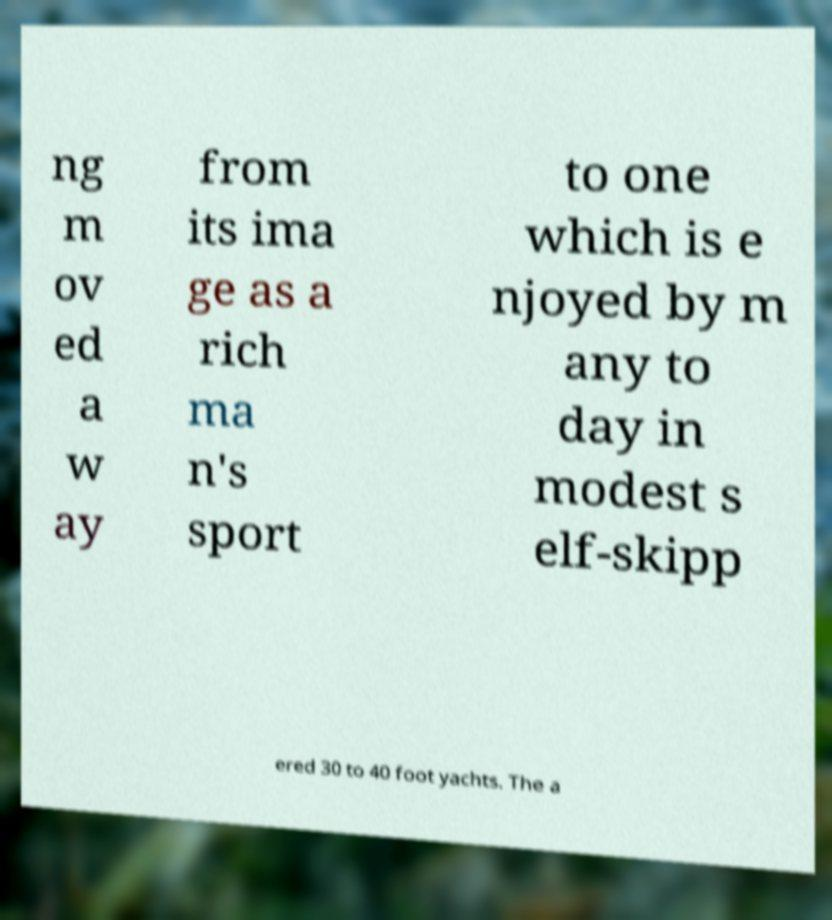Can you accurately transcribe the text from the provided image for me? ng m ov ed a w ay from its ima ge as a rich ma n's sport to one which is e njoyed by m any to day in modest s elf-skipp ered 30 to 40 foot yachts. The a 